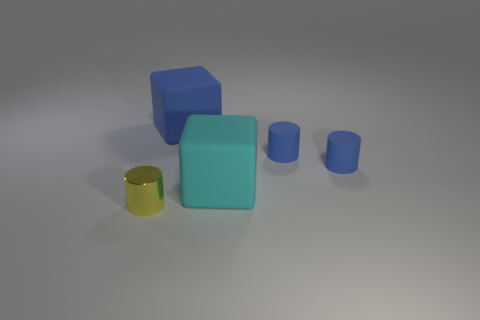What is the material and texture of the objects? The gold cylinder has a reflective, metallic texture, suggesting it is made of metal. The blue cubes and the cyan rubber object appear to have a matte finish, indicating that they are probably made of a non-metallic, possibly plastic or rubber-like material. 